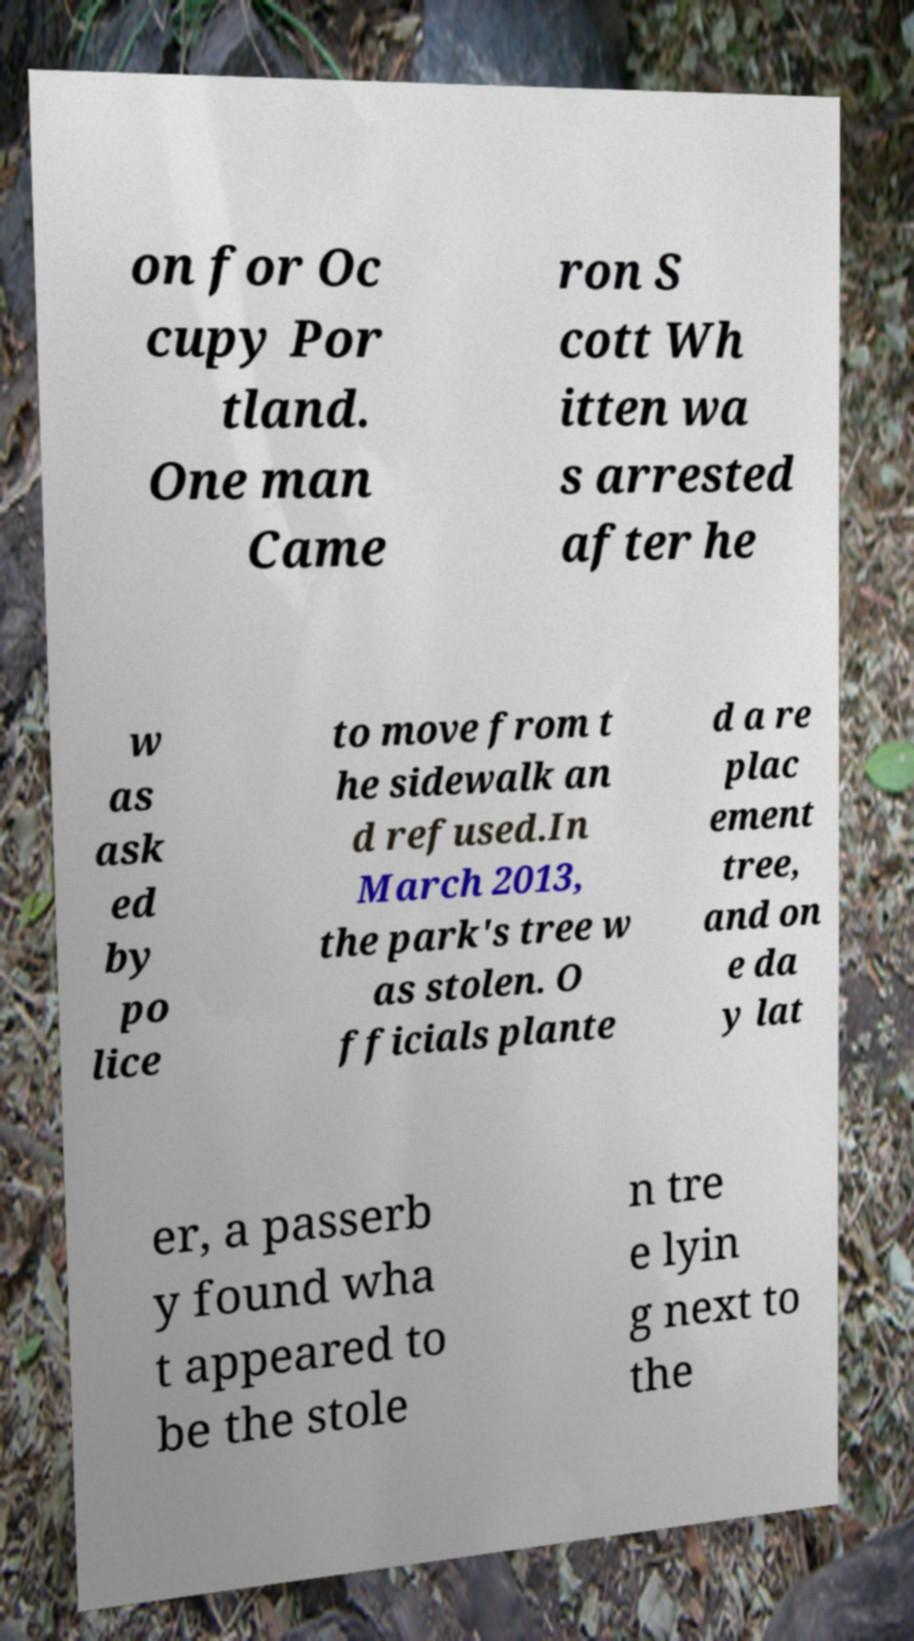Can you accurately transcribe the text from the provided image for me? on for Oc cupy Por tland. One man Came ron S cott Wh itten wa s arrested after he w as ask ed by po lice to move from t he sidewalk an d refused.In March 2013, the park's tree w as stolen. O fficials plante d a re plac ement tree, and on e da y lat er, a passerb y found wha t appeared to be the stole n tre e lyin g next to the 